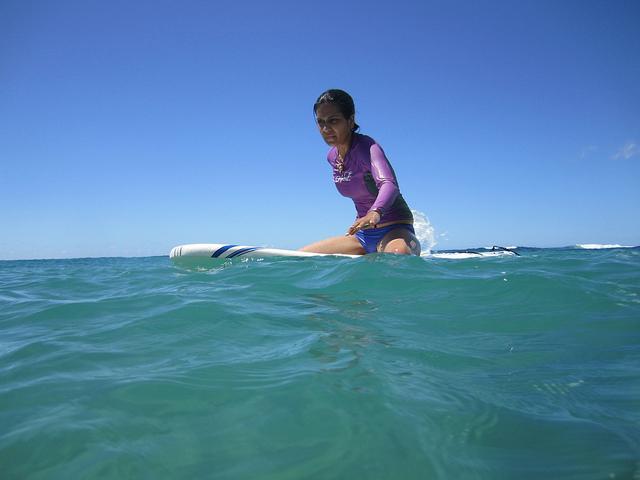What is she doing?
Give a very brief answer. Surfing. Where is he?
Keep it brief. Ocean. Are the waves big?
Answer briefly. No. 